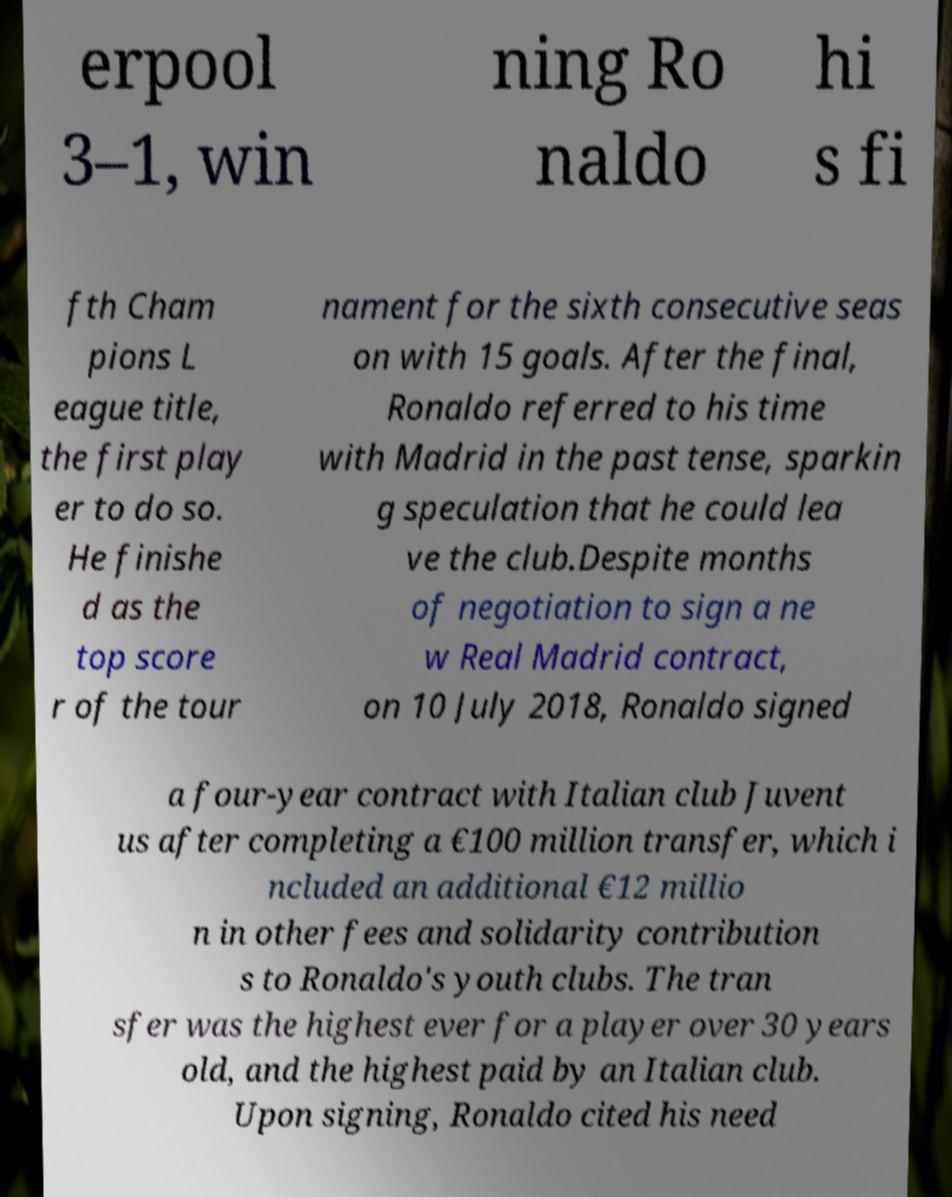There's text embedded in this image that I need extracted. Can you transcribe it verbatim? erpool 3–1, win ning Ro naldo hi s fi fth Cham pions L eague title, the first play er to do so. He finishe d as the top score r of the tour nament for the sixth consecutive seas on with 15 goals. After the final, Ronaldo referred to his time with Madrid in the past tense, sparkin g speculation that he could lea ve the club.Despite months of negotiation to sign a ne w Real Madrid contract, on 10 July 2018, Ronaldo signed a four-year contract with Italian club Juvent us after completing a €100 million transfer, which i ncluded an additional €12 millio n in other fees and solidarity contribution s to Ronaldo's youth clubs. The tran sfer was the highest ever for a player over 30 years old, and the highest paid by an Italian club. Upon signing, Ronaldo cited his need 